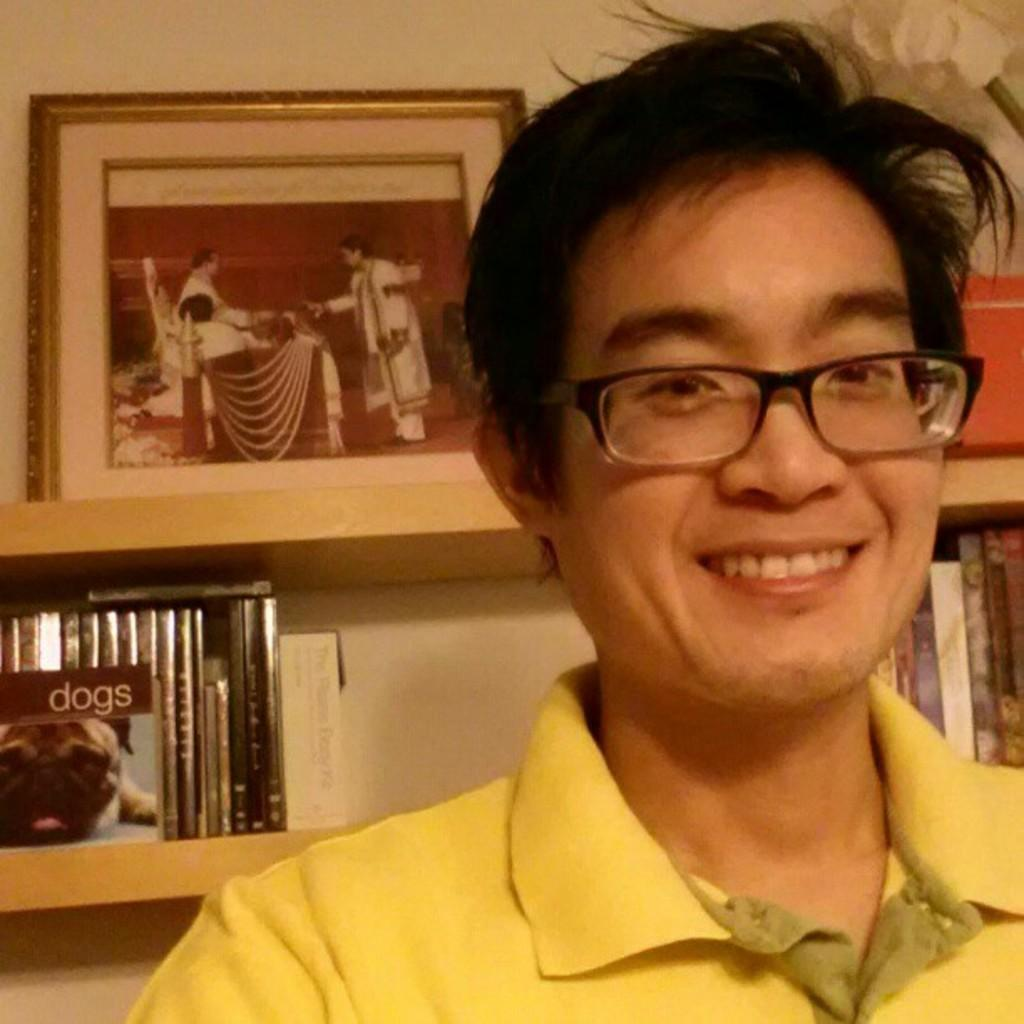What can be seen in the background of the image? In the background of the image, there is a frame and books and objects arranged in racks. Can you describe the man in the image? The man in the image is wearing spectacles and a yellow t-shirt, and he is smiling. What is the man's facial expression in the image? The man is smiling in the image. How many teeth can be seen in the image? There are no teeth visible in the image, as it features a man wearing spectacles and a yellow t-shirt, and smiling. What type of hall is depicted in the image? There is no hall present in the image; it features a man and a background with a frame and books arranged in racks. 